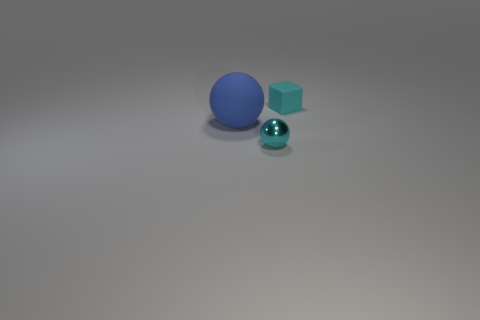Add 2 cyan shiny cylinders. How many objects exist? 5 Subtract all blocks. How many objects are left? 2 Subtract 0 red cylinders. How many objects are left? 3 Subtract all matte cubes. Subtract all tiny cyan rubber blocks. How many objects are left? 1 Add 3 tiny things. How many tiny things are left? 5 Add 2 metallic balls. How many metallic balls exist? 3 